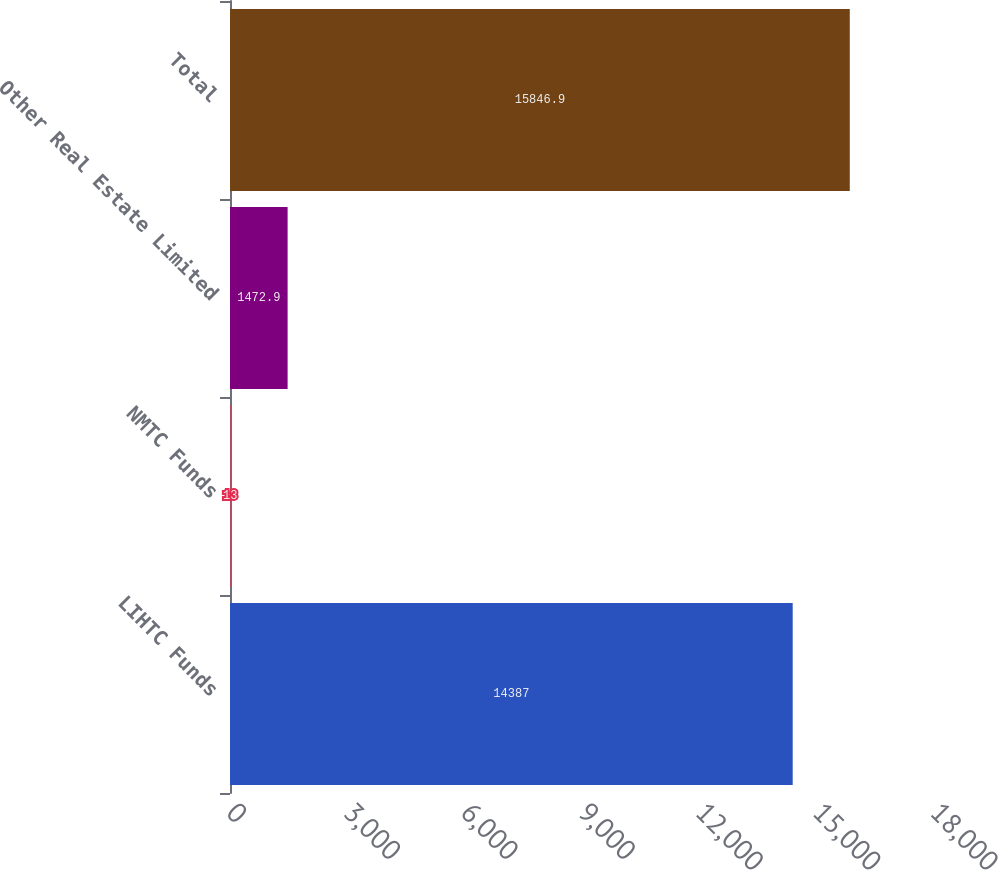Convert chart to OTSL. <chart><loc_0><loc_0><loc_500><loc_500><bar_chart><fcel>LIHTC Funds<fcel>NMTC Funds<fcel>Other Real Estate Limited<fcel>Total<nl><fcel>14387<fcel>13<fcel>1472.9<fcel>15846.9<nl></chart> 